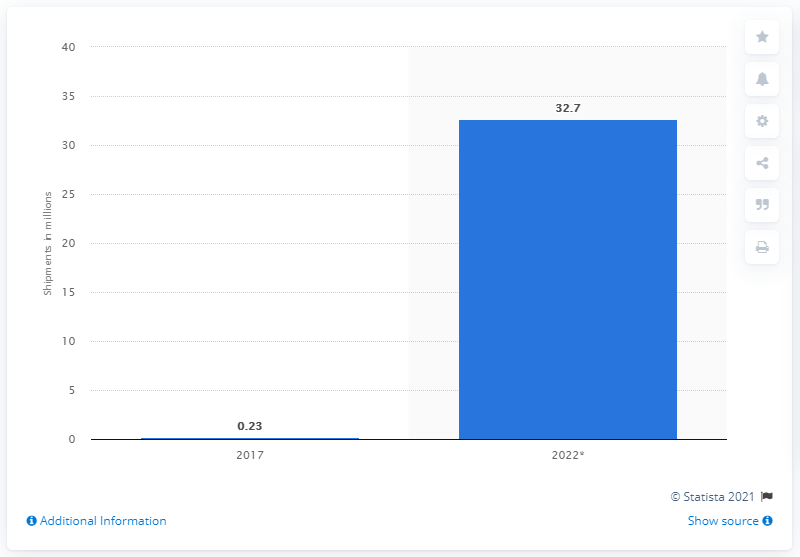List a handful of essential elements in this visual. The forecast for smart glasses unit shipments in 2022 is expected to be 32.7 million. 